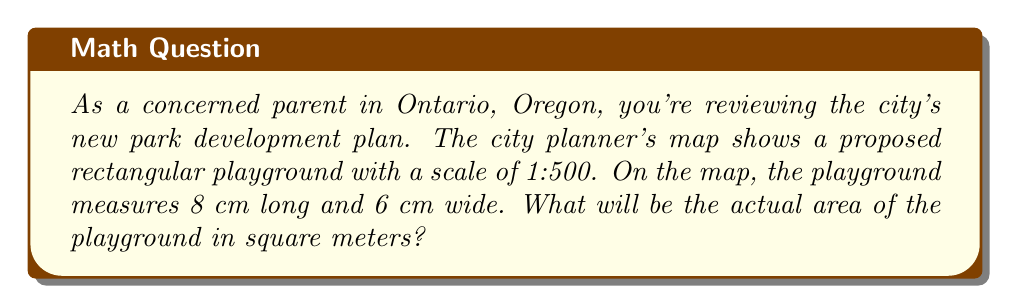What is the answer to this math problem? Let's approach this problem step-by-step:

1. Understand the scale:
   The scale is 1:500, which means 1 cm on the map represents 500 cm in real life.

2. Convert the map measurements to real-life measurements:
   - Length: $8 \text{ cm} \times 500 = 4000 \text{ cm} = 40 \text{ m}$
   - Width: $6 \text{ cm} \times 500 = 3000 \text{ cm} = 30 \text{ m}$

3. Calculate the area:
   Area = Length $\times$ Width
   $$A = 40 \text{ m} \times 30 \text{ m} = 1200 \text{ m}^2$$

Therefore, the actual area of the playground will be 1200 square meters.
Answer: $1200 \text{ m}^2$ 